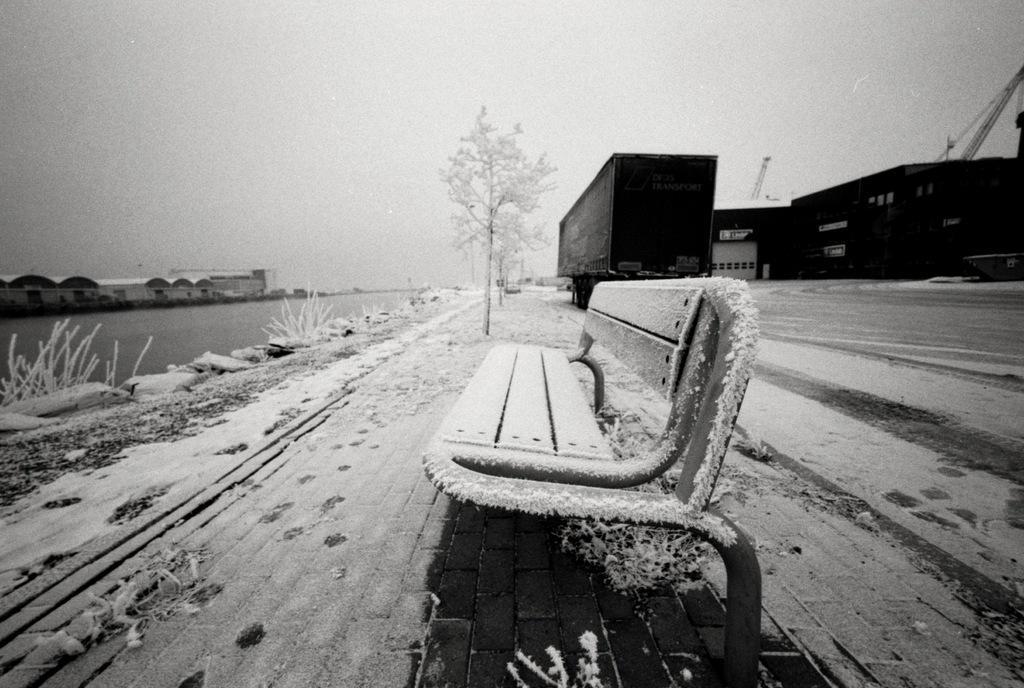In one or two sentences, can you explain what this image depicts? In this image there is a bench , trees, containers, water and houses covered with the snow, and in the background there is sky. 